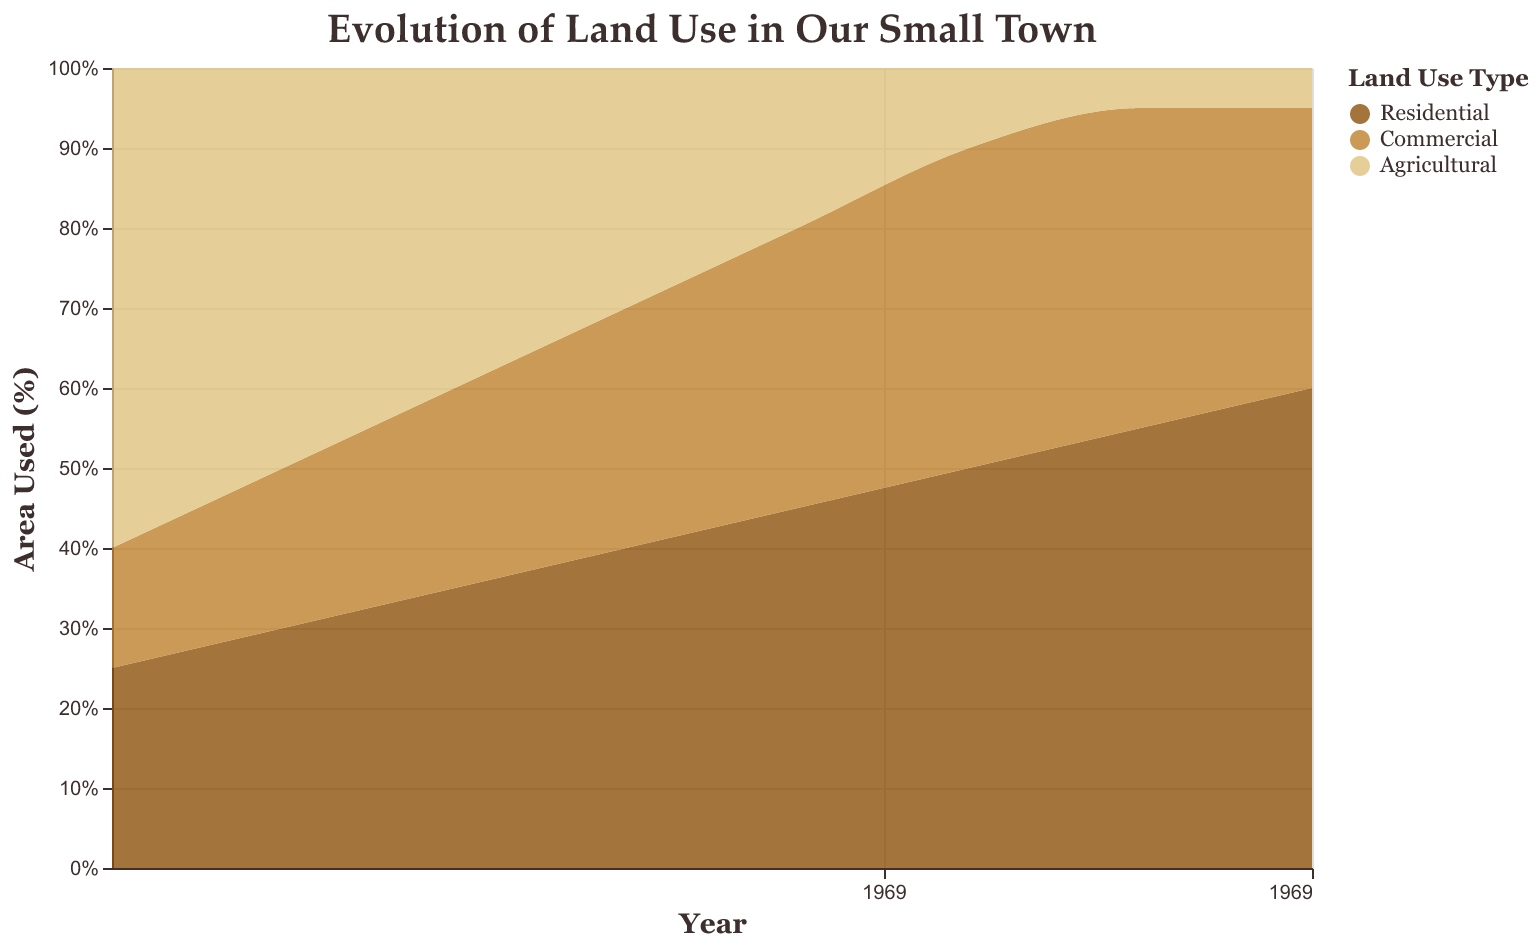What is the title of the figure? The figure's title, prominently displayed at the top, reads "Evolution of Land Use in Our Small Town".
Answer: Evolution of Land Use in Our Small Town What are the three categories of land use shown in the figure? The color legend on the right side of the figure indicates the three categories: Residential, Commercial, and Agricultural.
Answer: Residential, Commercial, Agricultural How did the area used for Residential land change from 1950 to 2020? According to the y-axis representing area used percentage and the x-axis timeline, the Residential area increased from 25% in 1950 to 60% in 2020.
Answer: Increased from 25% to 60% What proportion of land was used for Agricultural purposes in 1980? From the figure, in 1980, the percentage of area used for Agricultural purposes was 30%, as seen on the y-axis.
Answer: 30% Which land use category had the largest area in 1960? By examining the heights of the areas for each category in 1960, Agricultural had the highest proportion, which can be seen from the y-axis showing 50%.
Answer: Agricultural Between which years did Commercial land use see the most significant increase? Looking at the steepness of the increase on the Commercial land use line, the most significant growth occurred between 1950 and 2000, with a noticeable jump from 15% to 40%.
Answer: 1950-2000 What was the difference in Residential land use between 1990 and 2010? In 1990, the Residential land use was at 45%, and in 2010, it increased to 55%. The difference is calculated as 55% - 45%.
Answer: 10% In what year did Agricultural land use fall to its lowest, and what was the percentage? By looking at the smallest area for Agricultural use and referencing the y-axis, it reached its lowest in 2010 and 2020 at 5%.
Answer: 2010 and 2020, 5% How did land use for Commercial purposes in 2020 compare to that in 1960? In 1960, the Commercial land use was 20%, and in 2020, it was 35%. By comparing these values, we see an increase of 15%.
Answer: Increased by 15% 